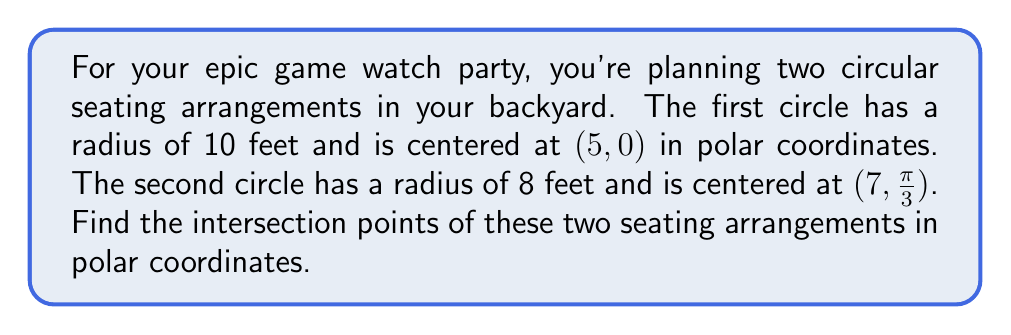Could you help me with this problem? To solve this problem, we'll follow these steps:

1) First, let's convert the center of the second circle from polar to Cartesian coordinates:
   $x = 7 \cos(\frac{\pi}{3}) = 3.5$
   $y = 7 \sin(\frac{\pi}{3}) = 6.06$

2) Now we have two circles in Cartesian coordinates:
   Circle 1: $(x-5)^2 + y^2 = 10^2$
   Circle 2: $(x-3.5)^2 + (y-6.06)^2 = 8^2$

3) To find the intersection points, we need to solve these equations simultaneously. This is complex, so we'll use a substitution method:

4) From the first equation:
   $y^2 = 100 - (x-5)^2 = 125 - 10x + x^2$

5) Substitute this into the second equation:
   $(x-3.5)^2 + (125 - 10x + x^2 - 6.06^2) = 64$

6) Simplify:
   $x^2 - 7x + 12.25 + 125 - 10x + x^2 - 36.72 = 64$
   $2x^2 - 17x + 36.53 = 0$

7) This is a quadratic equation. Solve using the quadratic formula:
   $x = \frac{17 \pm \sqrt{289 - 4(2)(36.53)}}{4} = \frac{17 \pm \sqrt{6.76}}{4}$

8) This gives us:
   $x_1 \approx 7.32$ and $x_2 \approx 1.18$

9) Substitute these back into $y^2 = 125 - 10x + x^2$ to find y:
   For $x_1$: $y_1 \approx \pm 6.83$
   For $x_2$: $y_2 \approx \pm 9.77$

10) Convert these Cartesian coordinates to polar:
    $r = \sqrt{x^2 + y^2}$, $\theta = \tan^{-1}(\frac{y}{x})$

    $(7.32, 6.83)$: $r \approx 10$, $\theta \approx 0.75$ radians
    $(7.32, -6.83)$: $r \approx 10$, $\theta \approx -0.75$ radians
    $(1.18, 9.77)$: $r \approx 9.84$, $\theta \approx 1.45$ radians
    $(1.18, -9.77)$: $r \approx 9.84$, $\theta \approx -1.45$ radians
Answer: The intersection points in polar coordinates are approximately:
$(10, 0.75)$, $(10, -0.75)$, $(9.84, 1.45)$, and $(9.84, -1.45)$, where the first number in each pair is the radius (in feet) and the second is the angle (in radians). 